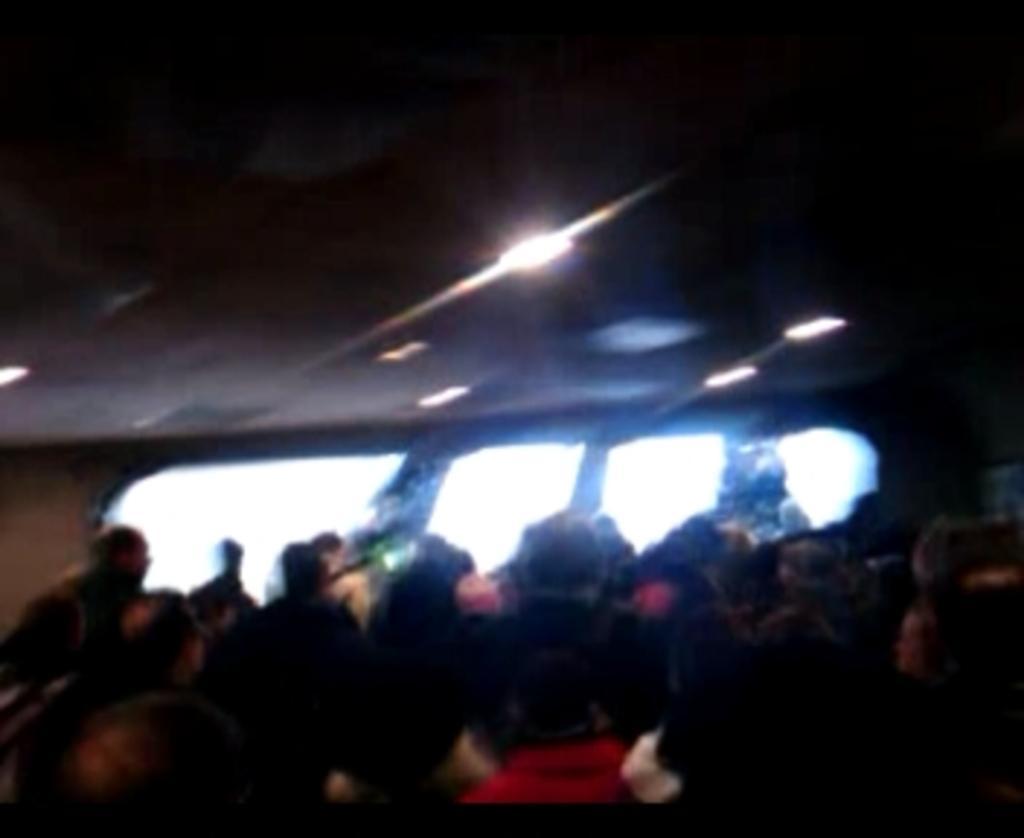Could you give a brief overview of what you see in this image? This image is blurry. In this image there are group of people. At the back it looks like windows. At the top there are lights. 